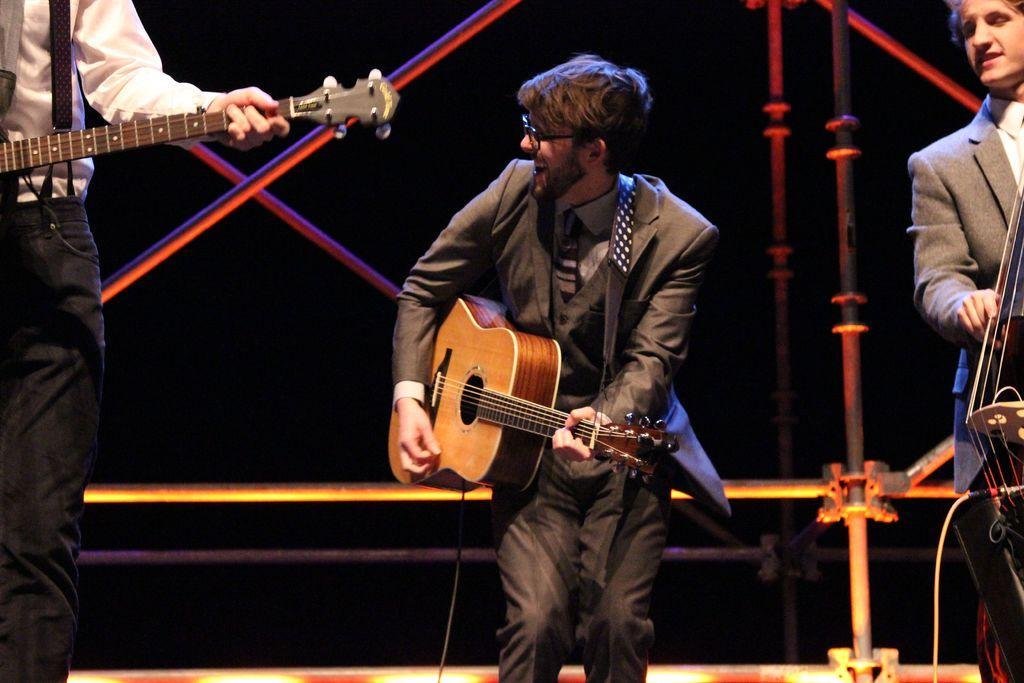Can you describe this image briefly? In this image there are three people. The man in the center is dancing and holding a guitar in his hand. On the left side the man is holding a guitar. On the right there is another man. 